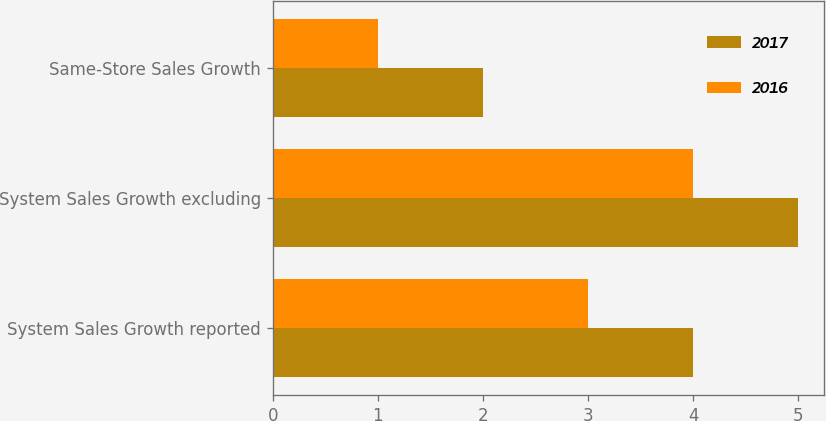<chart> <loc_0><loc_0><loc_500><loc_500><stacked_bar_chart><ecel><fcel>System Sales Growth reported<fcel>System Sales Growth excluding<fcel>Same-Store Sales Growth<nl><fcel>2017<fcel>4<fcel>5<fcel>2<nl><fcel>2016<fcel>3<fcel>4<fcel>1<nl></chart> 